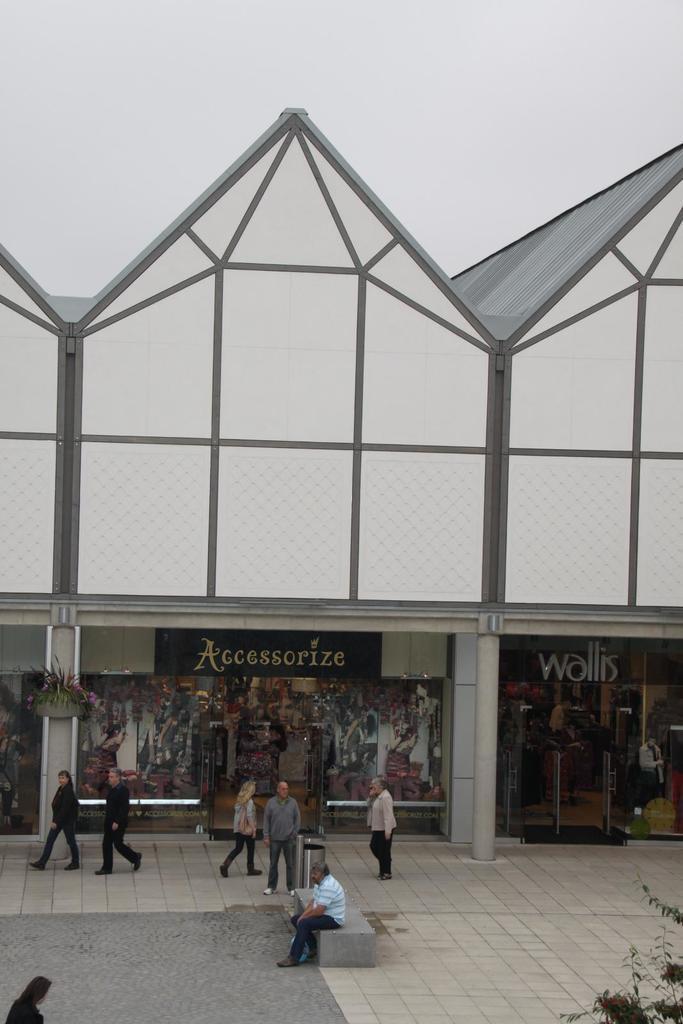Describe this image in one or two sentences. In this image I see a building and I see 2 stores over here and I see words written and I see few people in which this man is sitting over here and I see the path and I see the leaves on the stems. In the background I see the sky. 